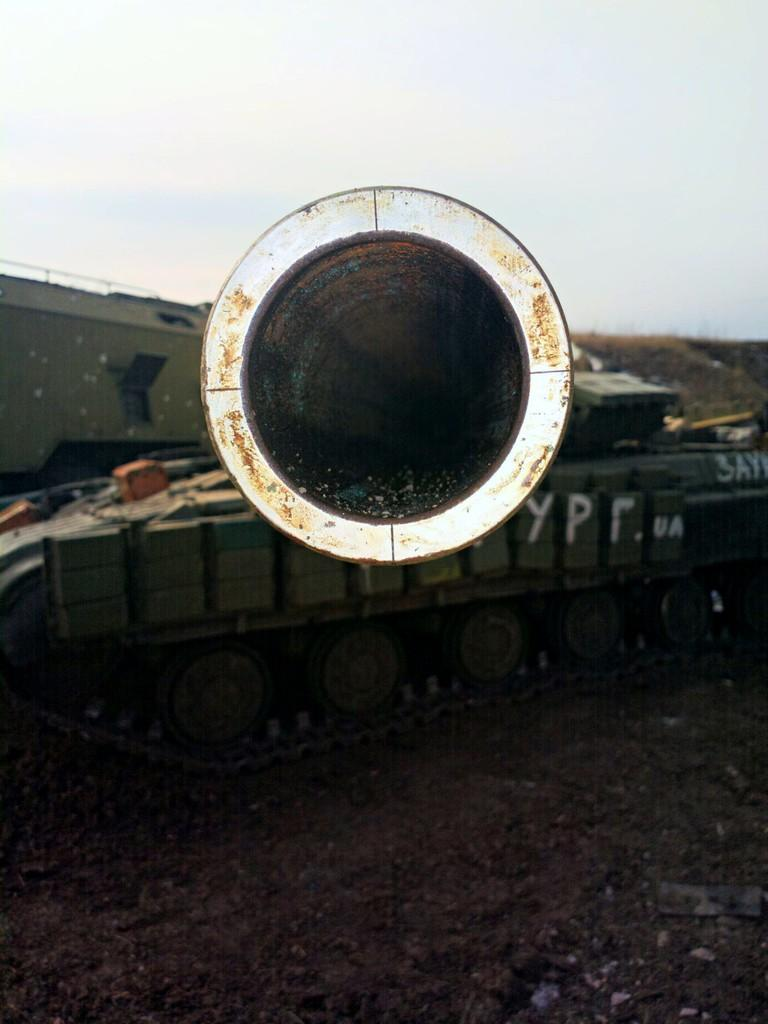What is the main subject of the image? The main subject of the image is a tanker. What color is the tanker? The tanker is dark green in color. Are there any markings or text on the tanker? Yes, there are alphabets written on the tanker. What can be seen below the tanker in the image? The ground is visible in the image. What is the condition of the sky in the background of the image? The sky is clear in the background of the image. Can you tell me how many balls are bouncing around the tanker in the image? There are no balls present in the image; it features a dark green tanker with alphabets on it. Is there a flame visible near the tanker in the image? There is no flame present in the image; it only features a dark green tanker with alphabets on it, the ground, and a clear sky in the background. 